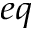<formula> <loc_0><loc_0><loc_500><loc_500>_ { e q }</formula> 